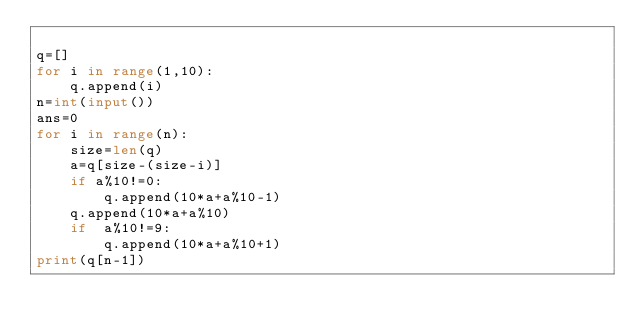Convert code to text. <code><loc_0><loc_0><loc_500><loc_500><_Python_>
q=[]
for i in range(1,10):
    q.append(i)
n=int(input())
ans=0
for i in range(n):
    size=len(q)
    a=q[size-(size-i)]
    if a%10!=0:
        q.append(10*a+a%10-1)
    q.append(10*a+a%10)
    if  a%10!=9:
        q.append(10*a+a%10+1)
print(q[n-1])</code> 